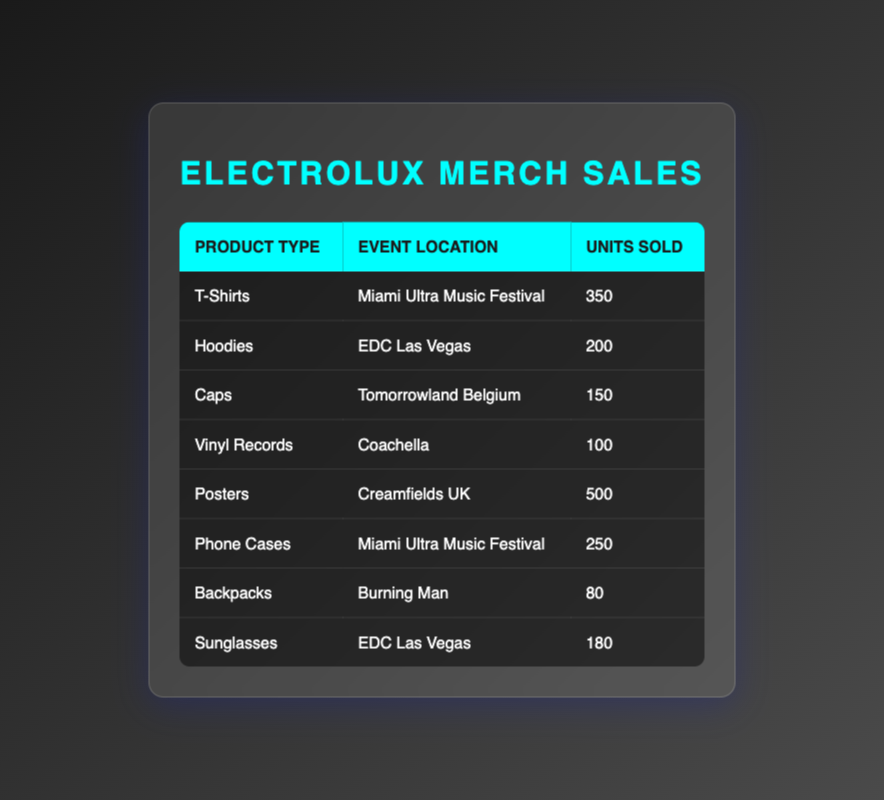What product type had the highest units sold? From the table, by comparing the "Units Sold" column for all product types, I can see that "Posters" recorded the highest sales with 500 units sold.
Answer: Posters How many units of Hoodies were sold at EDC Las Vegas? The table directly shows that 200 units of Hoodies were sold at EDC Las Vegas.
Answer: 200 Which event location sold the most total units? To determine the event location with the highest total units sold, I need to sum the units sold for each event: Miami Ultra Music Festival (350 + 250) = 600, EDC Las Vegas (200 + 180) = 380, Tomorrowland Belgium (150) = 150, Coachella (100) = 100, Creamfields UK (500) = 500, Burning Man (80) = 80. The highest total is for Miami Ultra Music Festival with 600 units.
Answer: Miami Ultra Music Festival Did Vinyl Records sell more than Sunglasses at Coachella? According to the table, Vinyl Records sold 100 units at Coachella, while Sunglasses were sold at EDC Las Vegas, not Coachella. Therefore, the comparison cannot be made directly, and the answer to whether Vinyl Records sold more than Sunglasses at Coachella is no.
Answer: No What is the total number of units sold for products at Miami Ultra Music Festival? To find the total units sold at Miami Ultra Music Festival, I will add the units sold for T-Shirts (350) and Phone Cases (250). The total is 350 + 250 = 600 units.
Answer: 600 Were more units of Caps sold at Tomorrowland Belgium than Backpacks sold at Burning Man? The table shows that 150 units of Caps were sold at Tomorrowland Belgium, and 80 units of Backpacks were sold at Burning Man. Since 150 is greater than 80, the answer is yes.
Answer: Yes How many units of products were sold at EDC Las Vegas in total? I will sum the units sold at EDC Las Vegas, which are Hoodies (200) and Sunglasses (180): 200 + 180 = 380 units sold in total.
Answer: 380 Which product type had the least sales? By reviewing the units sold for all product types in the table, it is evident that "Backpacks" with 80 units sold had the least sales.
Answer: Backpacks 